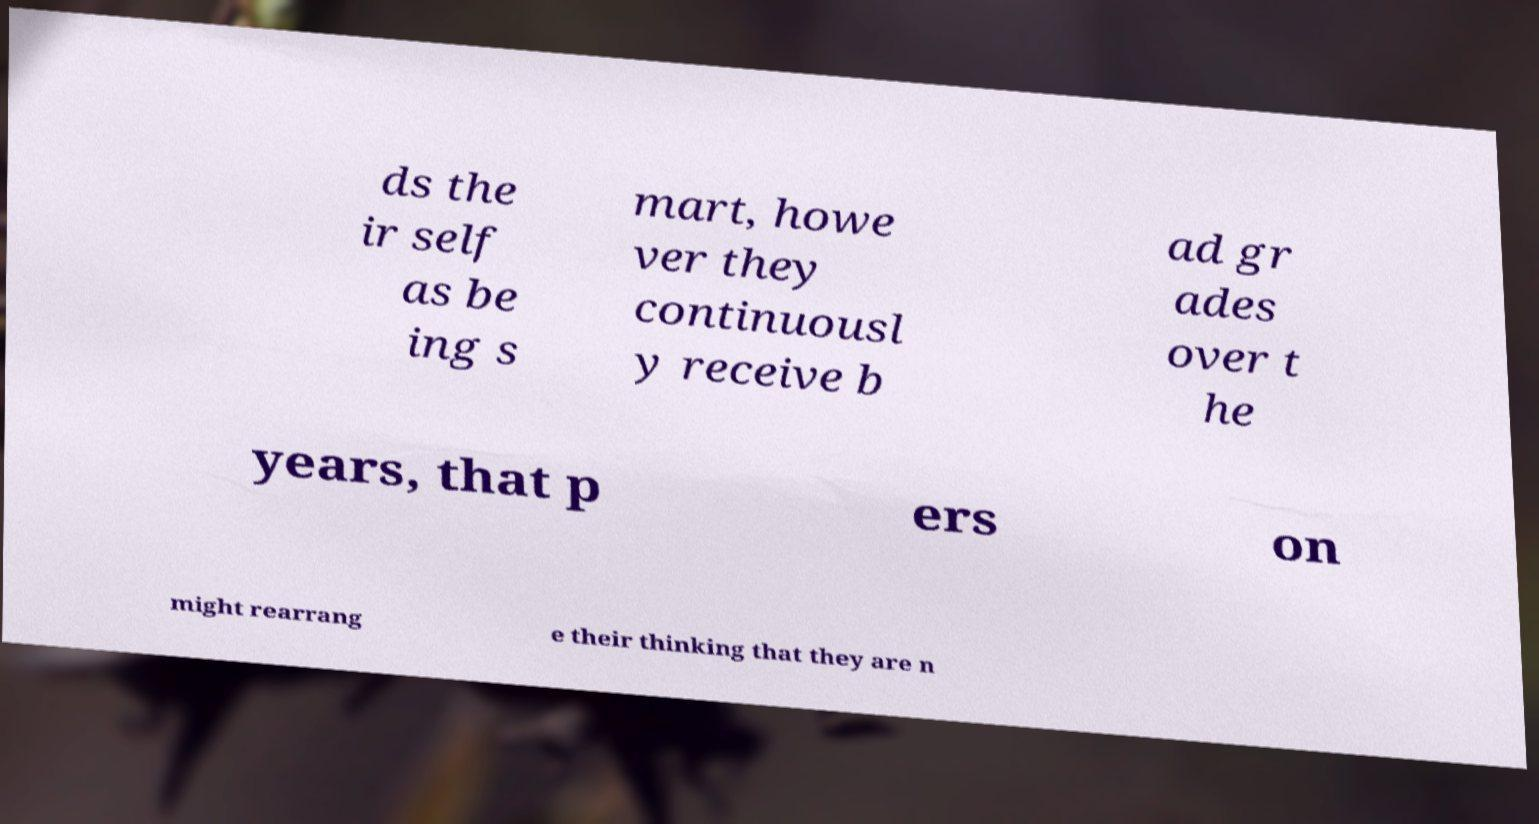What messages or text are displayed in this image? I need them in a readable, typed format. ds the ir self as be ing s mart, howe ver they continuousl y receive b ad gr ades over t he years, that p ers on might rearrang e their thinking that they are n 